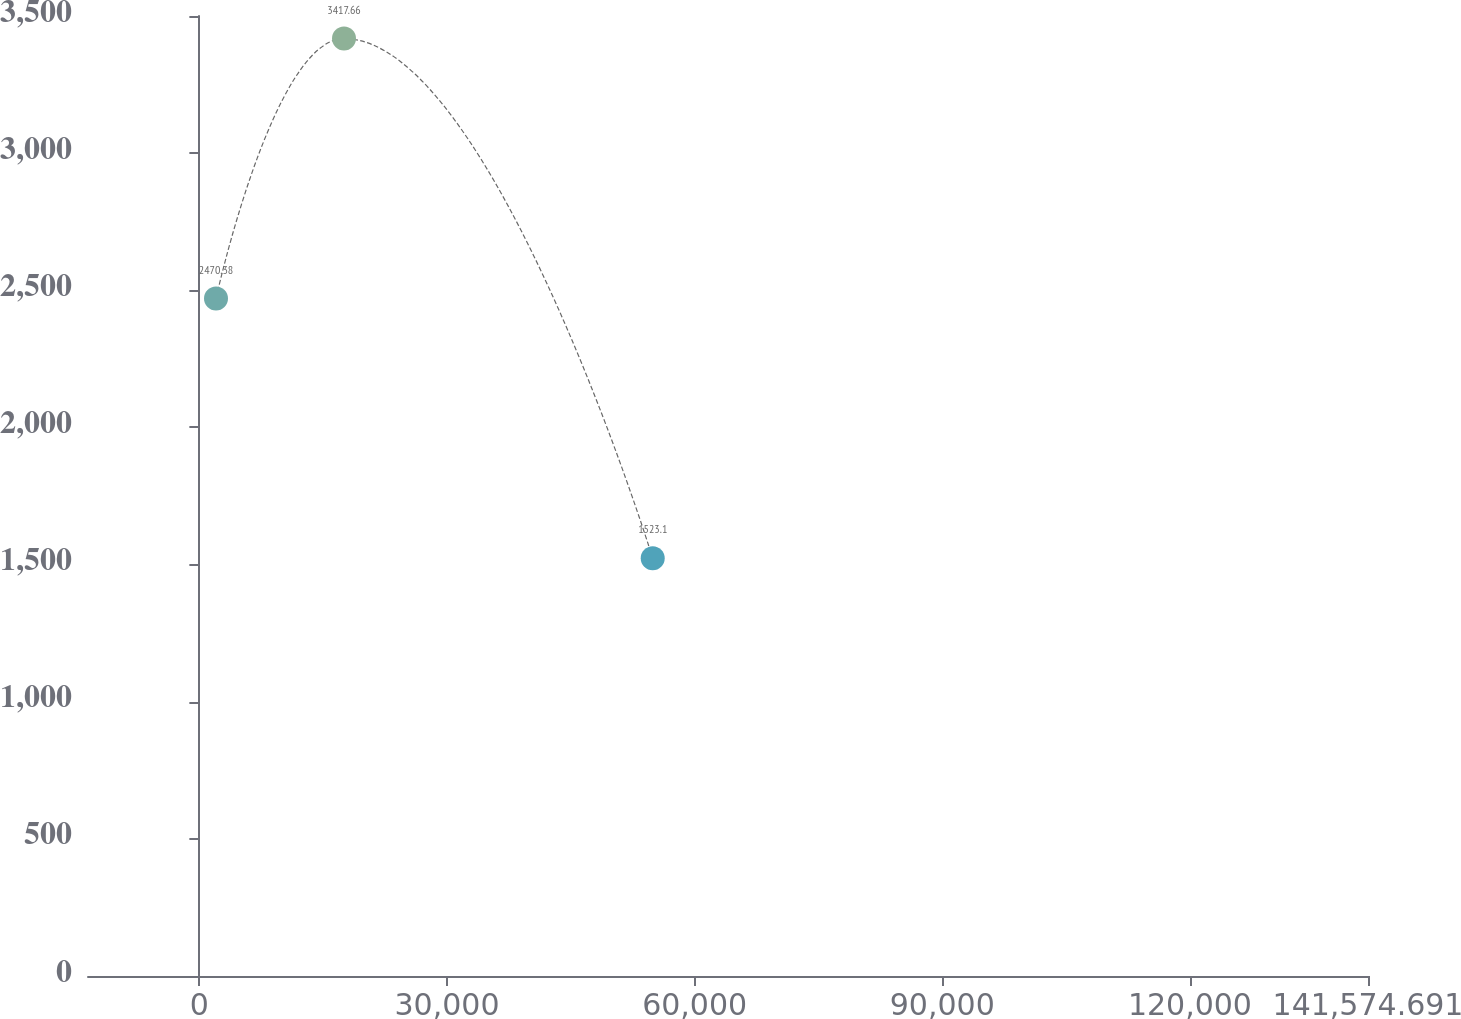Convert chart to OTSL. <chart><loc_0><loc_0><loc_500><loc_500><line_chart><ecel><fcel>Years Ended December 31,<nl><fcel>2015.93<fcel>2470.38<nl><fcel>17522.5<fcel>3417.66<nl><fcel>54921.7<fcel>1523.1<nl><fcel>157081<fcel>10995.9<nl></chart> 